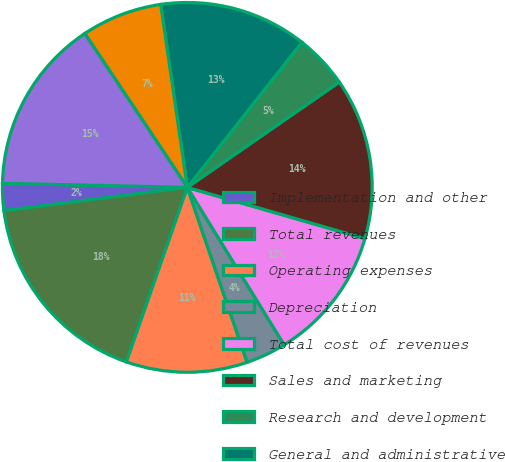<chart> <loc_0><loc_0><loc_500><loc_500><pie_chart><fcel>Implementation and other<fcel>Total revenues<fcel>Operating expenses<fcel>Depreciation<fcel>Total cost of revenues<fcel>Sales and marketing<fcel>Research and development<fcel>General and administrative<fcel>Depreciation and amortization<fcel>Total administrative expenses<nl><fcel>2.36%<fcel>17.64%<fcel>10.59%<fcel>3.53%<fcel>11.76%<fcel>14.11%<fcel>4.71%<fcel>12.94%<fcel>7.06%<fcel>15.29%<nl></chart> 